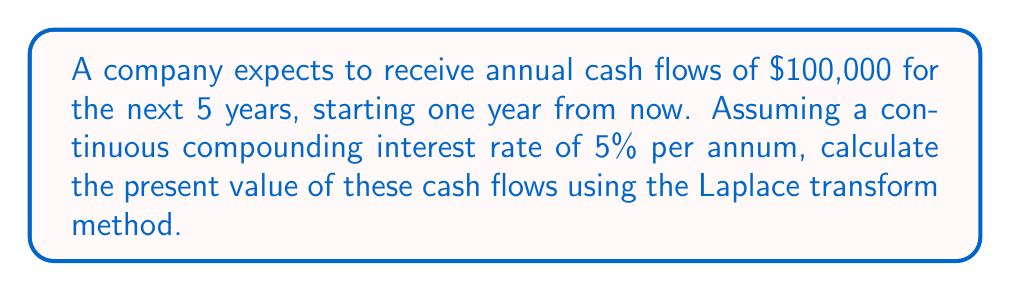Could you help me with this problem? To solve this problem using Laplace transforms, we'll follow these steps:

1) First, let's define our cash flow function. Since we have discrete annual payments, we can represent this as a sum of impulse functions:

   $$f(t) = 100000 \sum_{n=1}^{5} \delta(t-n)$$

2) The Laplace transform of this function is:

   $$F(s) = \mathcal{L}\{f(t)\} = 100000 \sum_{n=1}^{5} e^{-ns}$$

3) This is a geometric series with 5 terms. We can simplify it as:

   $$F(s) = 100000 \frac{e^{-s}(1-e^{-5s})}{1-e^{-s}}$$

4) The present value is given by $F(r)$, where $r$ is the interest rate. In this case, $r = 0.05$.

5) Substituting $s = 0.05$ into our equation:

   $$PV = F(0.05) = 100000 \frac{e^{-0.05}(1-e^{-0.25})}{1-e^{-0.05}}$$

6) Evaluating this expression:

   $$PV = 100000 \frac{0.9512(1-0.7788)}{1-0.9512} = 432947.49$$

Therefore, the present value of the cash flows is approximately $432,947.49.
Answer: $432,947.49 